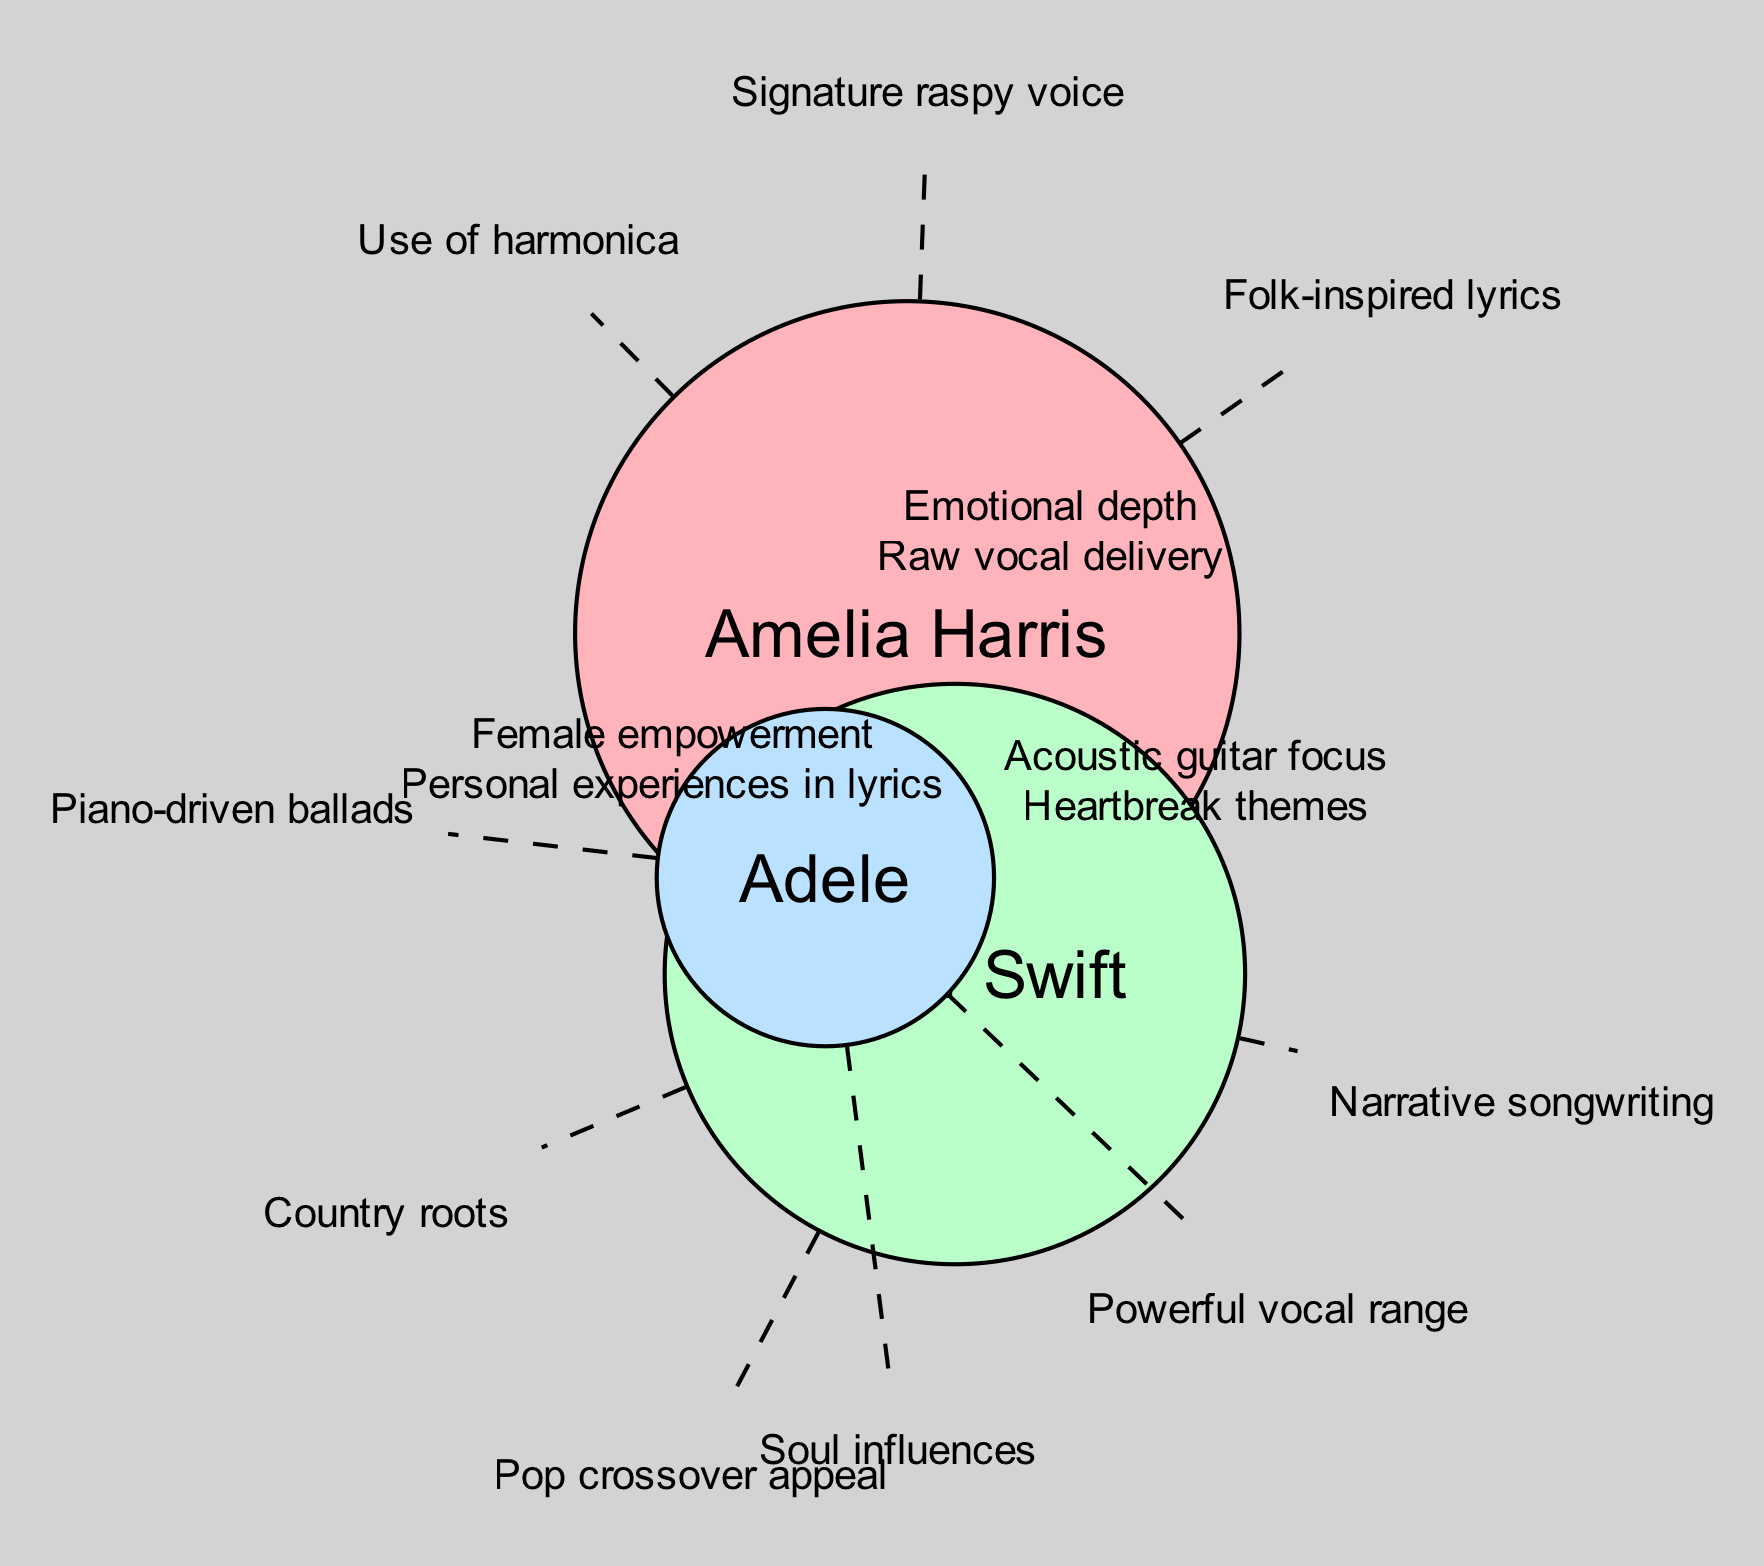What unique element describes Amelia Harris's musical style? In the diagram, one unique element listed for Amelia Harris is her "Signature raspy voice." This is directly associated with her circle in the Venn diagram.
Answer: Signature raspy voice How many unique elements does Taylor Swift have? Taylor Swift has three unique elements shown in her circle: "Country roots," "Narrative songwriting," and "Pop crossover appeal." Therefore, the total count of unique elements in her section is three.
Answer: 3 Which overlapping elements do Amelia Harris and Adele share? The diagram indicates that Amelia Harris and Adele have two overlapping elements: "Emotional depth" and "Raw vocal delivery." This information is derived from the section where their circles intersect.
Answer: Emotional depth, Raw vocal delivery What are the overlapping themes between all three artists? The diagram shows that all three artists, Amelia Harris, Taylor Swift, and Adele, share the overlapping themes of "Female empowerment" and "Personal experiences in lyrics." This is located in the intersection of all three circles.
Answer: Female empowerment, Personal experiences in lyrics Which artist has powerful vocal range as a unique element? In the Venn diagram, the unique element "Powerful vocal range" is specifically listed for Adele, which can be found in her designated circle.
Answer: Adele How many total artists are represented in the diagram? The diagram visually represents three artists: Amelia Harris, Taylor Swift, and Adele. Counting all circles gives a total of three artists included in the comparison.
Answer: 3 What unique characteristic is shared between Amelia Harris and Taylor Swift? The diagram shows that both Amelia Harris and Taylor Swift share overlapping elements of "Acoustic guitar focus" and "Heartbreak themes." This indicates the aspects of their styles that are common.
Answer: Acoustic guitar focus, Heartbreak themes Which color represents Amelia Harris in the diagram? The Venn diagram assigns the color '#FFB3BA' to Amelia Harris, which is visually indicated in her circle on the diagram.
Answer: #FFB3BA What element is exclusive to Adele regarding her musical style? The diagram states that "Soul influences" is a unique characteristic of Adele, which can be found in her corresponding circle.
Answer: Soul influences 